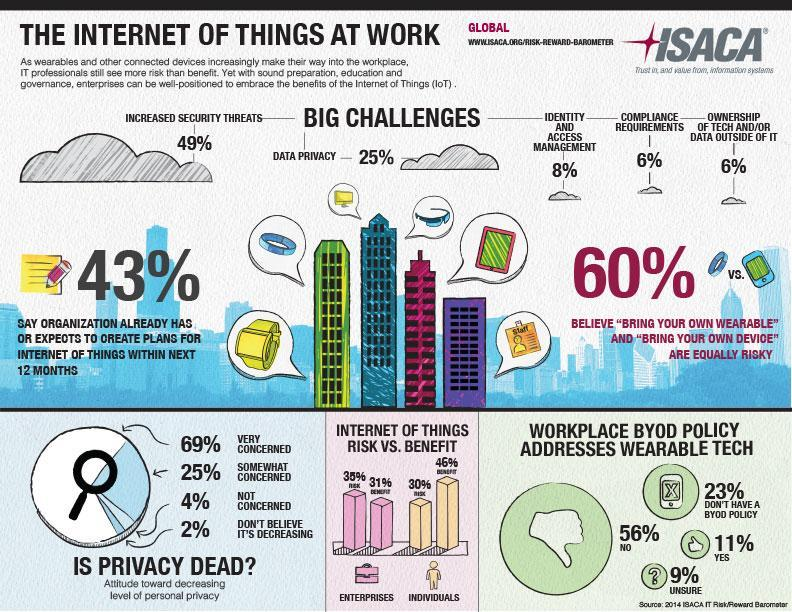What is the percentage of increased security threats?
Answer the question with a short phrase. 49% What percentage of organization has already created plans for IoT within next 12 months? 43% What percentage of benefits were provided by IoT on individual basis? 46% What is the percentage of ownership of tech and/or data outside of IT? 6% What percentage is the IoT risks in enterprises? 35% 